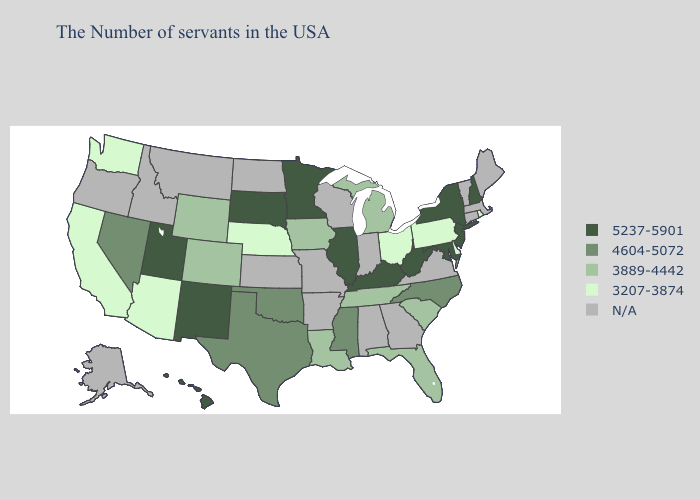Among the states that border Ohio , which have the lowest value?
Short answer required. Pennsylvania. Name the states that have a value in the range 5237-5901?
Write a very short answer. New Hampshire, New York, New Jersey, Maryland, West Virginia, Kentucky, Illinois, Minnesota, South Dakota, New Mexico, Utah, Hawaii. Which states have the highest value in the USA?
Answer briefly. New Hampshire, New York, New Jersey, Maryland, West Virginia, Kentucky, Illinois, Minnesota, South Dakota, New Mexico, Utah, Hawaii. Name the states that have a value in the range N/A?
Give a very brief answer. Maine, Massachusetts, Vermont, Connecticut, Virginia, Georgia, Indiana, Alabama, Wisconsin, Missouri, Arkansas, Kansas, North Dakota, Montana, Idaho, Oregon, Alaska. What is the value of Delaware?
Short answer required. 3207-3874. What is the value of Nebraska?
Short answer required. 3207-3874. Does the first symbol in the legend represent the smallest category?
Write a very short answer. No. Does Louisiana have the highest value in the South?
Keep it brief. No. What is the lowest value in the USA?
Concise answer only. 3207-3874. What is the lowest value in the Northeast?
Quick response, please. 3207-3874. How many symbols are there in the legend?
Short answer required. 5. What is the value of Illinois?
Answer briefly. 5237-5901. How many symbols are there in the legend?
Be succinct. 5. What is the lowest value in states that border Louisiana?
Keep it brief. 4604-5072. 